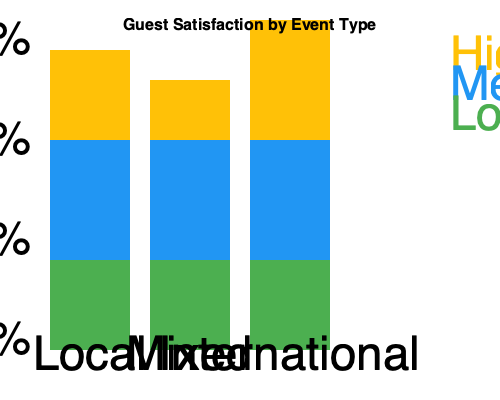As a retired school teacher organizing cultural events for guests, you analyze the impact of cultural diversity on guest satisfaction. Based on the stacked bar chart, which type of cultural event yields the highest percentage of highly satisfied guests, and what implications does this have for future event planning? To answer this question, we need to analyze the stacked bar chart and follow these steps:

1. Understand the chart:
   - The x-axis represents three types of cultural events: Local, Mixed, and International.
   - The y-axis shows the percentage of guest satisfaction from 0% to 100%.
   - Each bar is divided into three levels of satisfaction: High (yellow), Medium (blue), and Low (green).

2. Compare the "High Satisfaction" (yellow) portions for each event type:
   - Local events: approximately 30% high satisfaction
   - Mixed events: approximately 20% high satisfaction
   - International events: approximately 36% high satisfaction

3. Identify the highest percentage:
   International events have the highest percentage of highly satisfied guests at about 36%.

4. Consider implications for future event planning:
   a) Prioritize international events to maximize high satisfaction rates.
   b) Investigate what aspects of international events contribute to higher satisfaction.
   c) Consider incorporating elements of international events into local and mixed events.
   d) Balance the event calendar with a focus on international events while maintaining diversity.
   e) Gather feedback from guests to understand preferences and cultural interests.
   f) Develop strategies to improve satisfaction rates for local and mixed events.
   g) Use the success of international events as a benchmark for other event types.

5. Remember the importance of maintaining a diverse event calendar:
   While international events show the highest satisfaction, a mix of all types ensures catering to various preferences and promotes cultural exchange.
Answer: International events; prioritize these while maintaining diversity and improving other event types. 